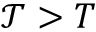<formula> <loc_0><loc_0><loc_500><loc_500>\mathcal { T } > T</formula> 